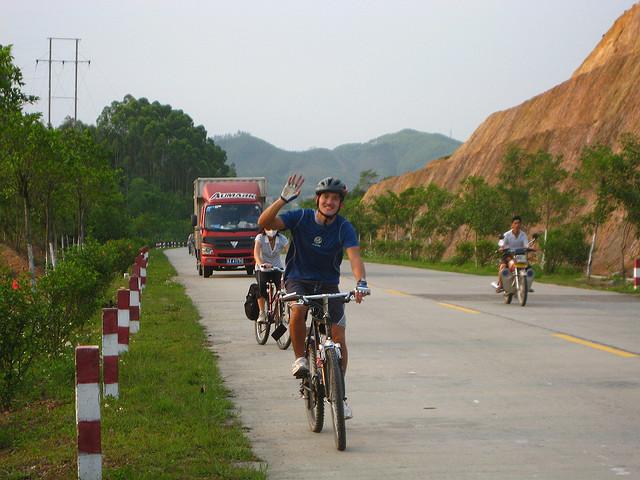How many bicycles are there?
Answer briefly. 3. Are people riding the bikes?
Keep it brief. Yes. How many bikes are here?
Answer briefly. 3. What is this scene at?
Keep it brief. Street. What is the person doing?
Answer briefly. Waving. Is the man doing  move?
Quick response, please. Yes. What vehicle is that?
Be succinct. Bicycle. What color are the barriers?
Short answer required. Red and white. Who is riding the bike?
Answer briefly. Man. Is this a dirt bike?
Give a very brief answer. No. What sport is this person in?
Give a very brief answer. Cycling. What are these people riding?
Give a very brief answer. Bikes. How many red and white post are there?
Write a very short answer. 7. Does the truck wish the bikers would get out of his way?
Quick response, please. Yes. What is this sport called?
Short answer required. Cycling. What country does this scene appear to be taken in?
Be succinct. Usa. Which sport is this?
Give a very brief answer. Cycling. Where are these bikes located?
Keep it brief. Road. What separates the road from the cliffside?
Concise answer only. Trees. Will he get dirty if he falls?
Be succinct. Yes. What type of vehicle is headed towards the camera?
Quick response, please. Bicycle. What are the people riding?
Give a very brief answer. Bikes. What is this person riding on?
Answer briefly. Bike. 